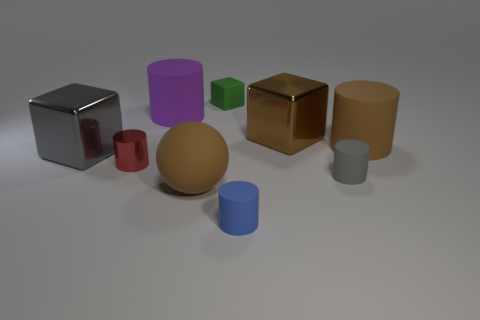Subtract all red cylinders. How many cylinders are left? 4 Subtract all brown cylinders. How many cylinders are left? 4 Add 1 small cylinders. How many objects exist? 10 Subtract all purple cylinders. Subtract all gray spheres. How many cylinders are left? 4 Subtract 0 yellow blocks. How many objects are left? 9 Subtract all balls. How many objects are left? 8 Subtract all yellow blocks. How many cyan cylinders are left? 0 Subtract all metal things. Subtract all small blue metallic cubes. How many objects are left? 6 Add 8 big brown cylinders. How many big brown cylinders are left? 9 Add 4 shiny blocks. How many shiny blocks exist? 6 